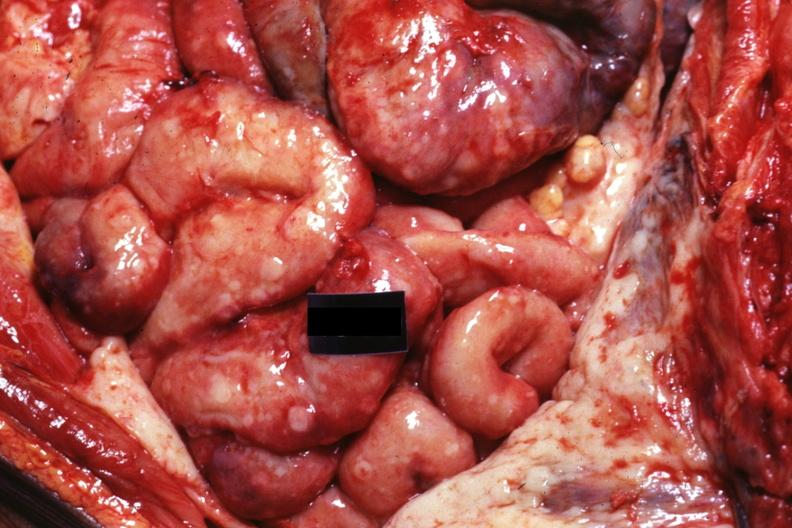s granulomata slide present?
Answer the question using a single word or phrase. No 